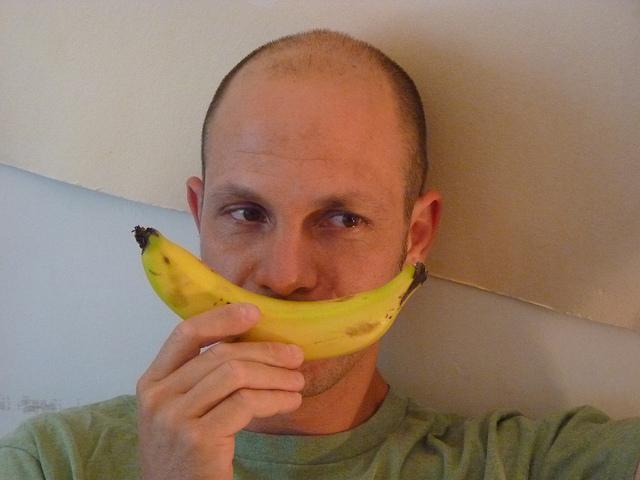How many types of bikes do you see?
Give a very brief answer. 0. 